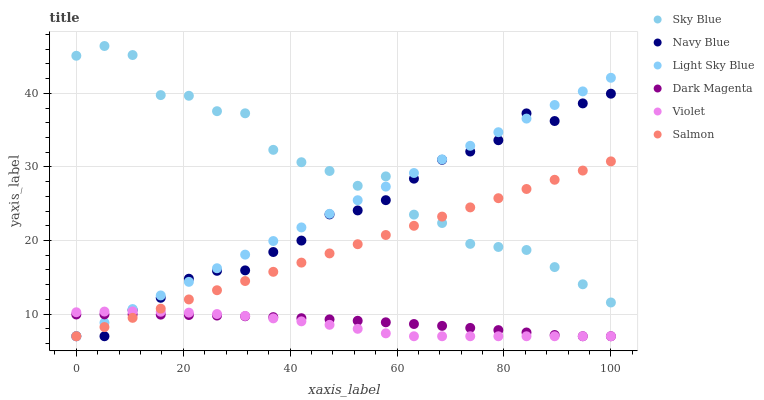Does Violet have the minimum area under the curve?
Answer yes or no. Yes. Does Sky Blue have the maximum area under the curve?
Answer yes or no. Yes. Does Navy Blue have the minimum area under the curve?
Answer yes or no. No. Does Navy Blue have the maximum area under the curve?
Answer yes or no. No. Is Salmon the smoothest?
Answer yes or no. Yes. Is Sky Blue the roughest?
Answer yes or no. Yes. Is Navy Blue the smoothest?
Answer yes or no. No. Is Navy Blue the roughest?
Answer yes or no. No. Does Dark Magenta have the lowest value?
Answer yes or no. Yes. Does Sky Blue have the lowest value?
Answer yes or no. No. Does Sky Blue have the highest value?
Answer yes or no. Yes. Does Navy Blue have the highest value?
Answer yes or no. No. Is Dark Magenta less than Sky Blue?
Answer yes or no. Yes. Is Sky Blue greater than Dark Magenta?
Answer yes or no. Yes. Does Dark Magenta intersect Violet?
Answer yes or no. Yes. Is Dark Magenta less than Violet?
Answer yes or no. No. Is Dark Magenta greater than Violet?
Answer yes or no. No. Does Dark Magenta intersect Sky Blue?
Answer yes or no. No. 